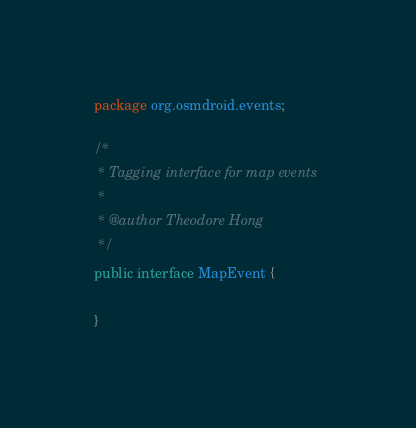Convert code to text. <code><loc_0><loc_0><loc_500><loc_500><_Java_>package org.osmdroid.events;

/*
 * Tagging interface for map events
 *
 * @author Theodore Hong
 */
public interface MapEvent {

}
</code> 